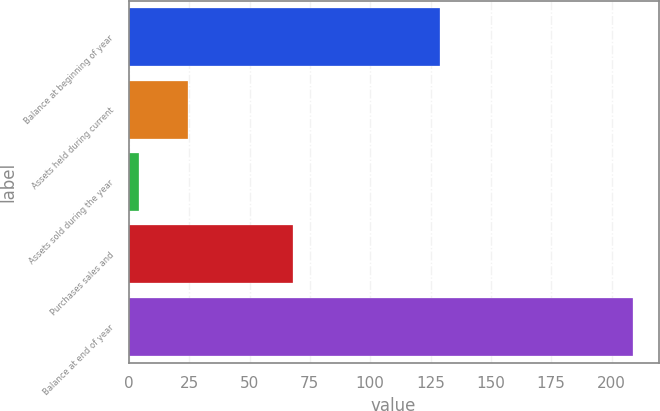Convert chart. <chart><loc_0><loc_0><loc_500><loc_500><bar_chart><fcel>Balance at beginning of year<fcel>Assets held during current<fcel>Assets sold during the year<fcel>Purchases sales and<fcel>Balance at end of year<nl><fcel>129<fcel>24.5<fcel>4<fcel>68<fcel>209<nl></chart> 